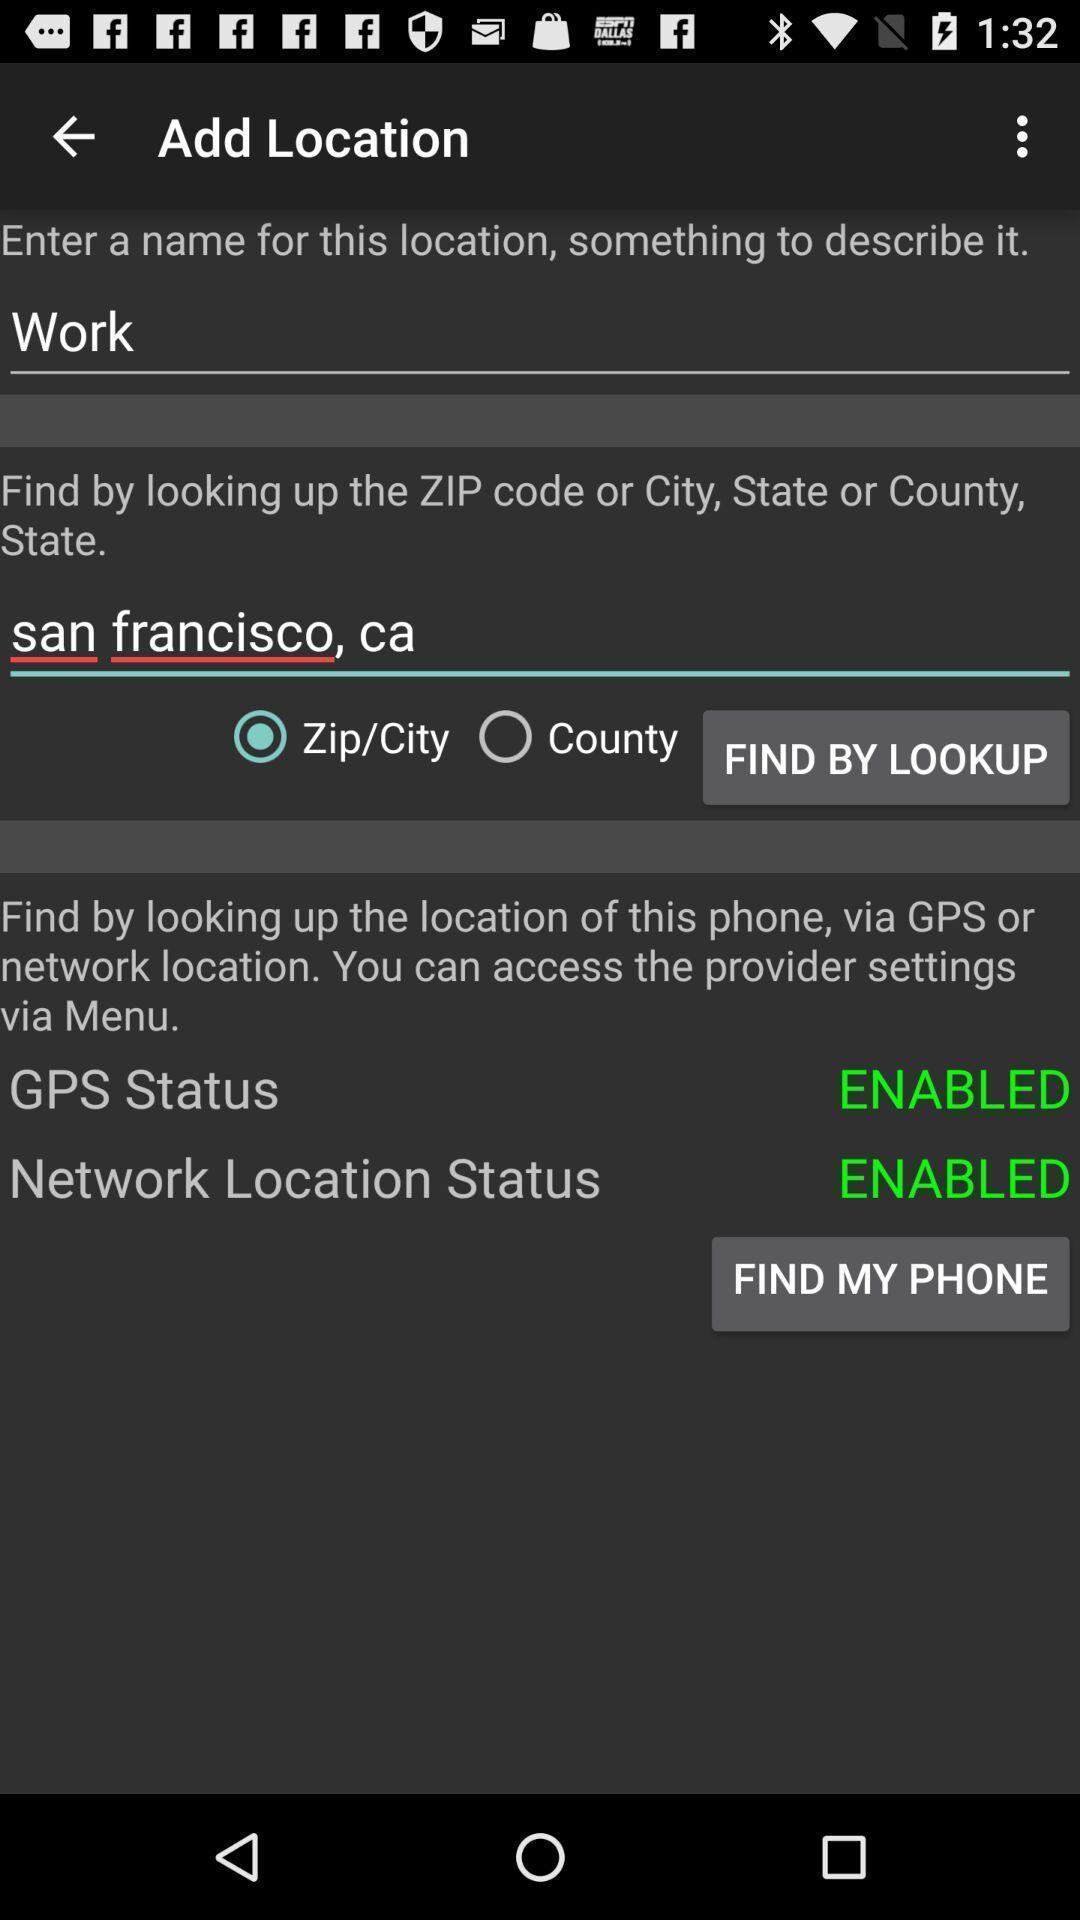Explain the elements present in this screenshot. Screen showing add location. 